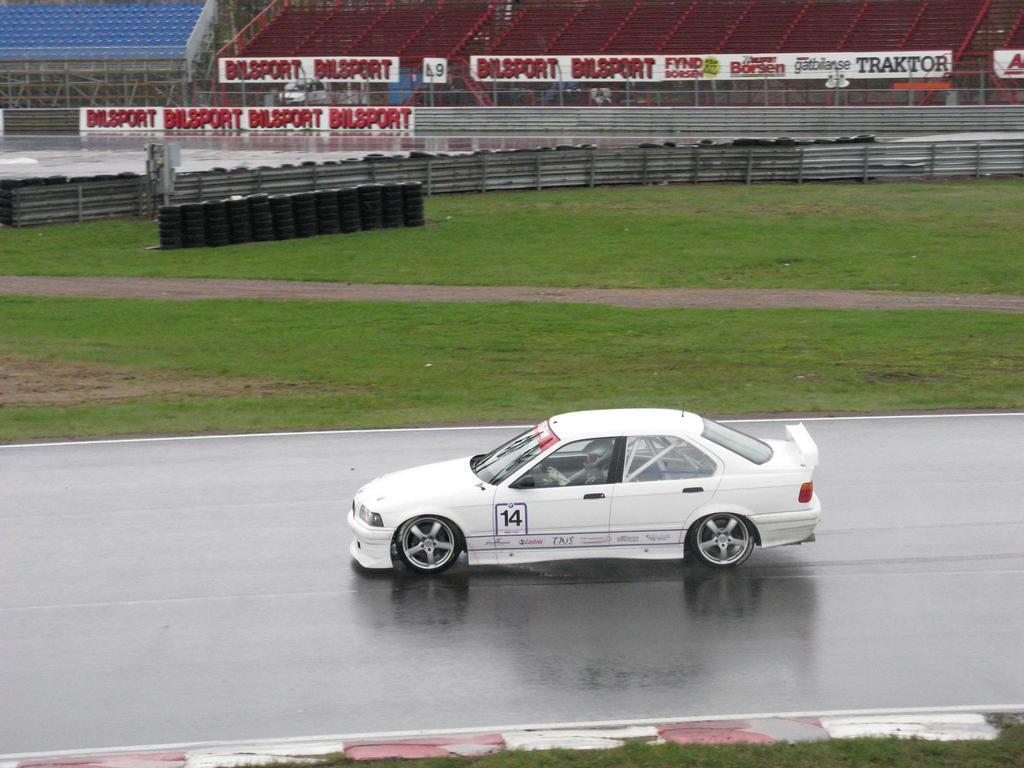How would you summarize this image in a sentence or two? In this image I can see a white color car on the road which is facing towards the left side. Inside the car there is a person sitting. On both sides of the road I can see the green color grass. On the top of the image there are some stairs, boards and a wall. On the left side there are few wheels on the ground. 